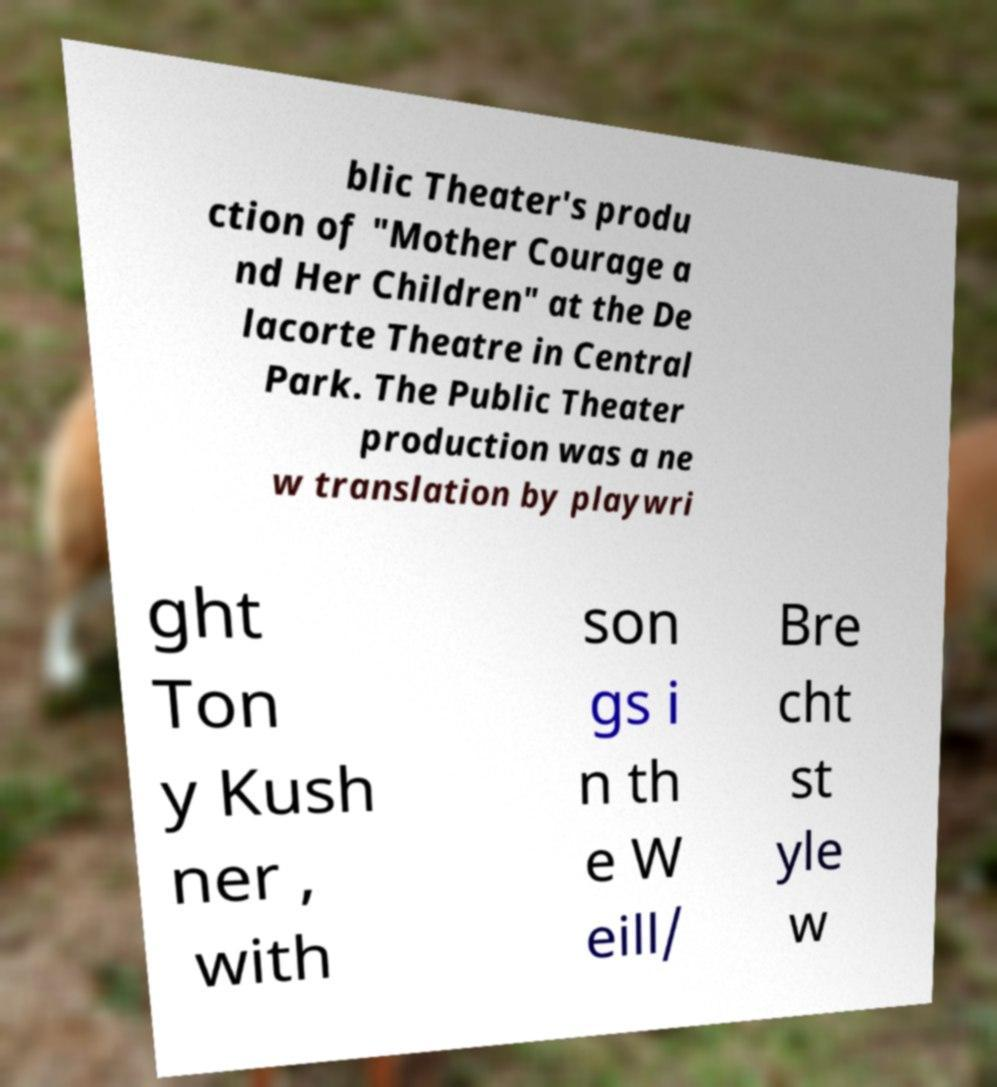Can you read and provide the text displayed in the image?This photo seems to have some interesting text. Can you extract and type it out for me? blic Theater's produ ction of "Mother Courage a nd Her Children" at the De lacorte Theatre in Central Park. The Public Theater production was a ne w translation by playwri ght Ton y Kush ner , with son gs i n th e W eill/ Bre cht st yle w 